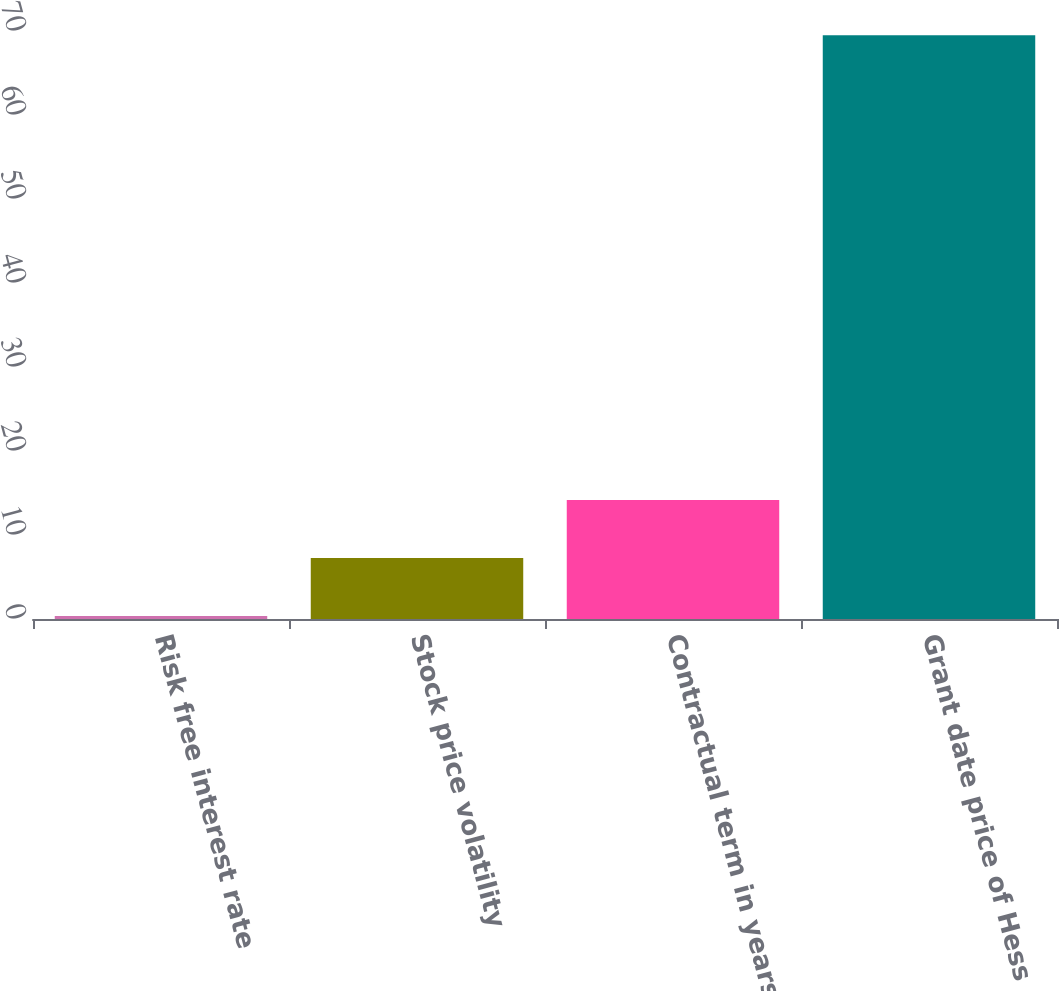<chart> <loc_0><loc_0><loc_500><loc_500><bar_chart><fcel>Risk free interest rate<fcel>Stock price volatility<fcel>Contractual term in years<fcel>Grant date price of Hess<nl><fcel>0.36<fcel>7.27<fcel>14.18<fcel>69.49<nl></chart> 